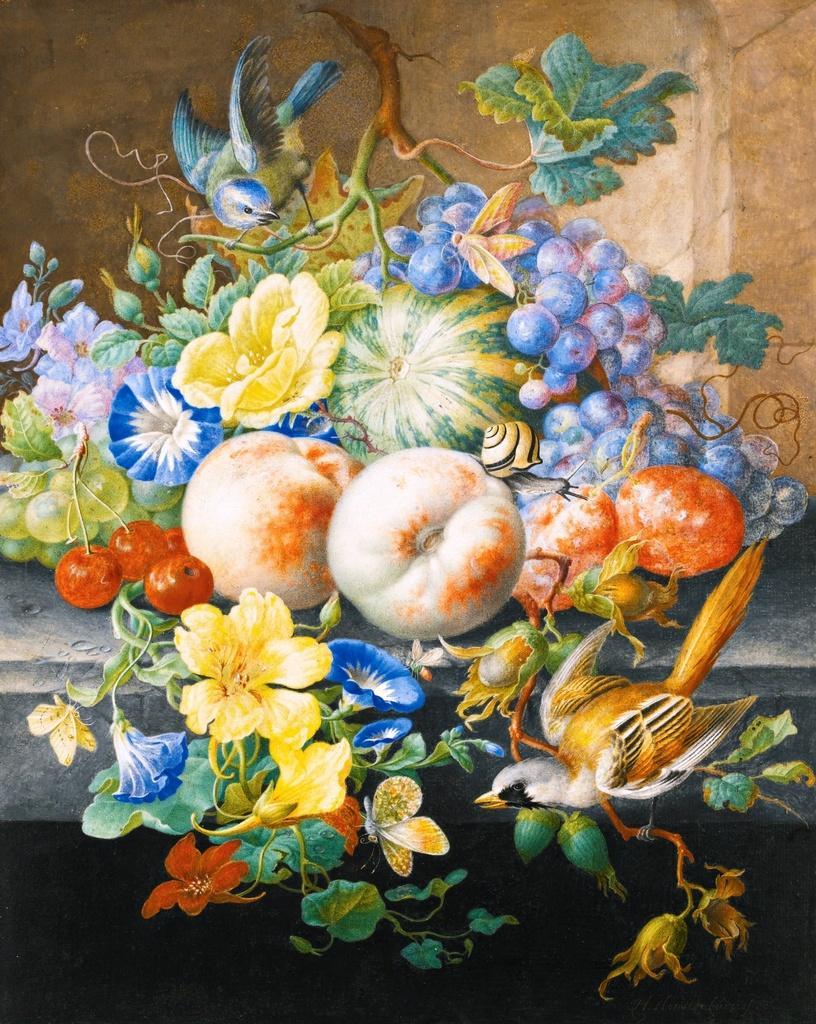Could you give a brief overview of what you see in this image? This image consists of an art of a few fruits, flowers, a creeper and birds. 